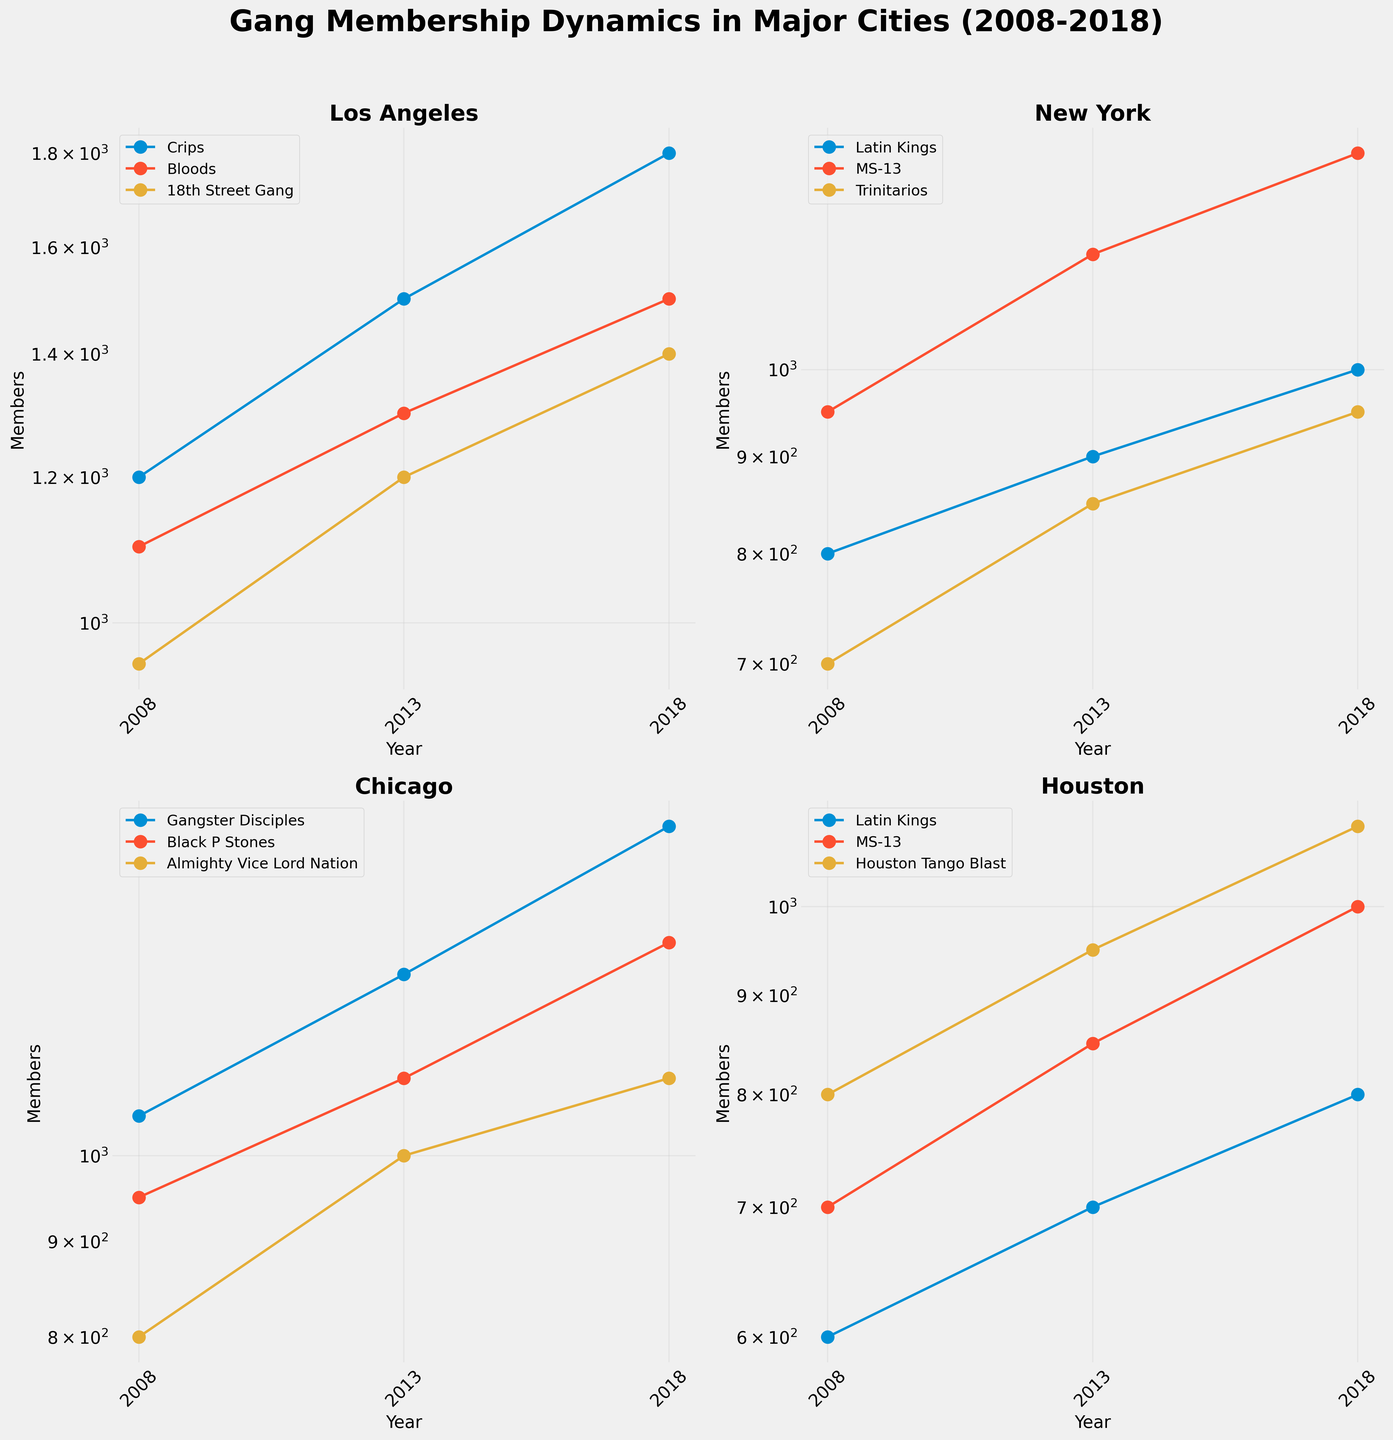How many gang organizations are represented in the four subplots? Each subplot represents a different city, and within each city, multiple gang organizations are represented. By briefly looking at the legends for each subplot, we can count the number of unique gang names.
Answer: 12 Which city has seen the highest increase in gang membership for any gang from 2008 to 2018? To determine this, examine the changes in membership for each gang in all cities by comparing the 2018 data to the 2008 data. "Crips" in Los Angeles increased from 1200 in 2008 to 1800 in 2018.
Answer: Los Angeles (Crips) Which city has the smallest change in the number of gang members in any gang from 2008 to 2018? Compare gang numbers for each city from 2008 to 2018. For each gang, calculate the absolute difference in members between 2008 and 2018. "Latin Kings" in Houston changed from 600 to 800 members.
Answer: Houston (Latin Kings) What is the trend of gang membership in Chicago for the "Black P Stones" between 2008 and 2018? Look at the plot for Chicago and trace the line for "Black P Stones" from 2008 to 2018. Observe if the number of members increased, decreased, or remained stable. Membership increased steadily from 950 to 1300.
Answer: Increasing Which gang in New York has the highest number of members in 2018? Find the data point corresponding to 2018 in the New York subplot. Among the gangs, "MS-13" has the highest membership at 1300.
Answer: MS-13 How does the membership growth of "Houston Tango Blast" in Houston compare to "Gangster Disciples" in Chicago from 2008 to 2018? Calculate the increase for both gangs: "Houston Tango Blast" grew from 800 to 1100 (an increase of 300); "Gangster Disciples" grew from 1050 to 1500 (an increase of 450).
Answer: Chicago (Gangster Disciples) What trend is observed in the overall gang membership in Los Angeles between 2008 and 2018? Analyze the aggregate membership numbers of all gangs in Los Angeles, noting the general direction. Membership for each gang—Crips, Bloods, and 18th Street Gang—increased over these years.
Answer: Increasing Between "Trinitarios" in New York and "Bloods" in Los Angeles, which experienced a higher percentage increase in members from 2008 to 2018? Calculate the percentage increase for both: "Trinitarios" from 700 to 950 (35.7% increase), "Bloods" from 1100 to 1500 (36.4% increase).
Answer: Los Angeles (Bloods) What was the total number of gang members in Houston in 2013? Sum the number of members for "Latin Kings", "MS-13", and "Houston Tango Blast" in Houston for 2013: 700 + 850 + 950.
Answer: 2500 